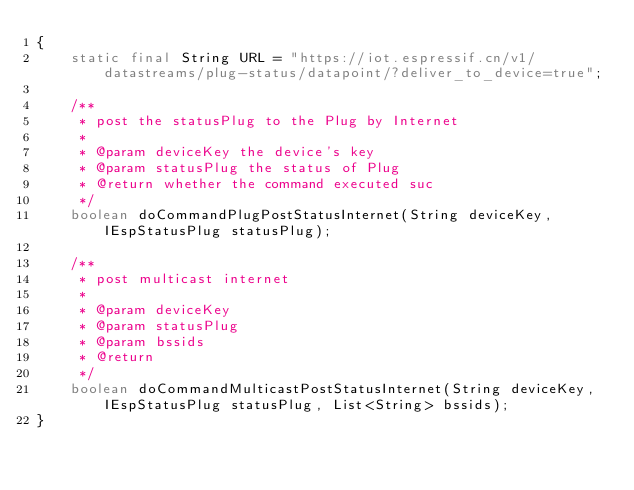<code> <loc_0><loc_0><loc_500><loc_500><_Java_>{
    static final String URL = "https://iot.espressif.cn/v1/datastreams/plug-status/datapoint/?deliver_to_device=true";
    
    /**
     * post the statusPlug to the Plug by Internet
     * 
     * @param deviceKey the device's key
     * @param statusPlug the status of Plug
     * @return whether the command executed suc
     */
    boolean doCommandPlugPostStatusInternet(String deviceKey, IEspStatusPlug statusPlug);
    
    /**
     * post multicast internet
     * 
     * @param deviceKey
     * @param statusPlug
     * @param bssids
     * @return
     */
    boolean doCommandMulticastPostStatusInternet(String deviceKey, IEspStatusPlug statusPlug, List<String> bssids);
}
</code> 